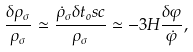Convert formula to latex. <formula><loc_0><loc_0><loc_500><loc_500>\frac { \delta \rho _ { \sigma } } { \rho _ { \sigma } } \simeq \frac { \dot { \rho } _ { \sigma } \delta t _ { o } s c } { \rho _ { \sigma } } \simeq - 3 H \frac { \delta \varphi } { \dot { \varphi } } ,</formula> 